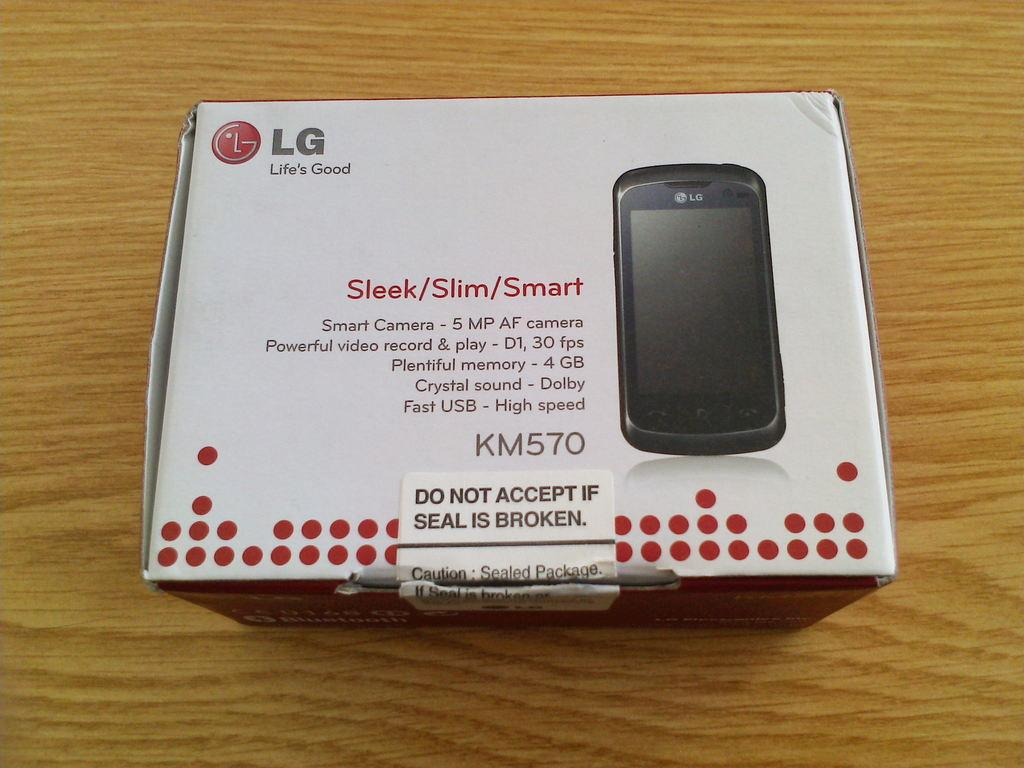Provide a one-sentence caption for the provided image. A new cell phone with KM570 on iy. 